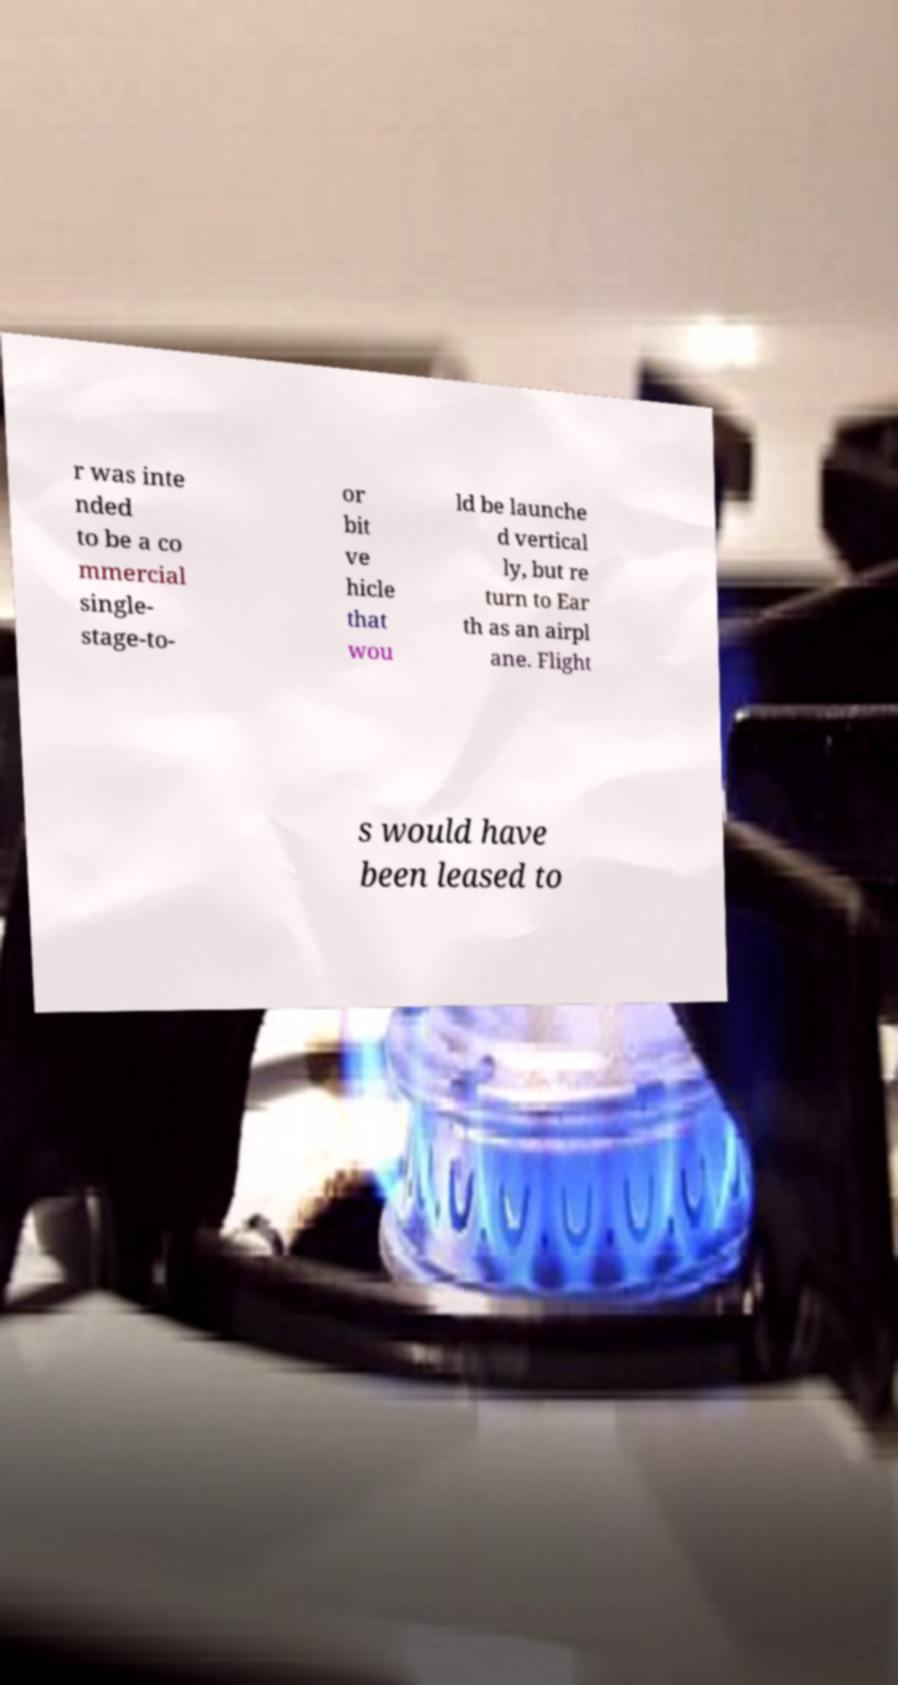Could you assist in decoding the text presented in this image and type it out clearly? r was inte nded to be a co mmercial single- stage-to- or bit ve hicle that wou ld be launche d vertical ly, but re turn to Ear th as an airpl ane. Flight s would have been leased to 